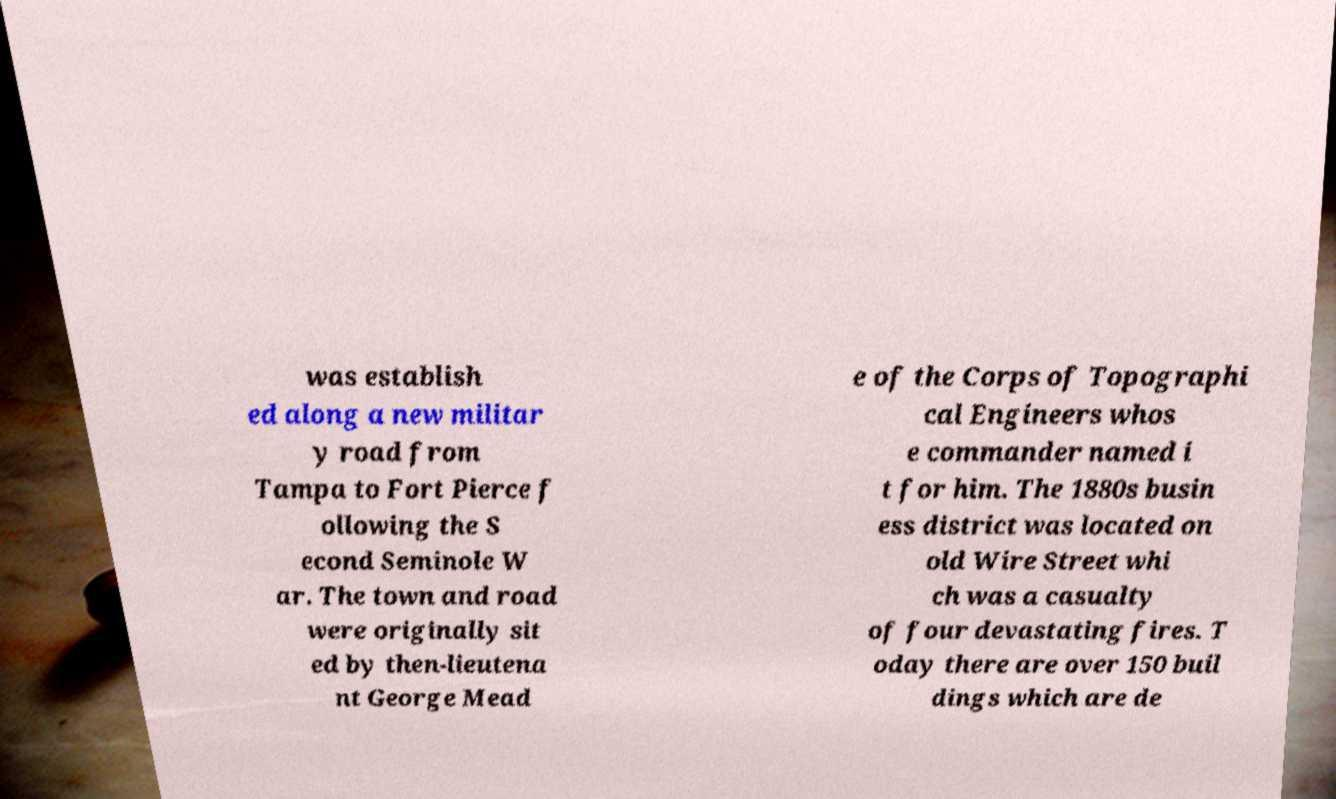Can you accurately transcribe the text from the provided image for me? was establish ed along a new militar y road from Tampa to Fort Pierce f ollowing the S econd Seminole W ar. The town and road were originally sit ed by then-lieutena nt George Mead e of the Corps of Topographi cal Engineers whos e commander named i t for him. The 1880s busin ess district was located on old Wire Street whi ch was a casualty of four devastating fires. T oday there are over 150 buil dings which are de 